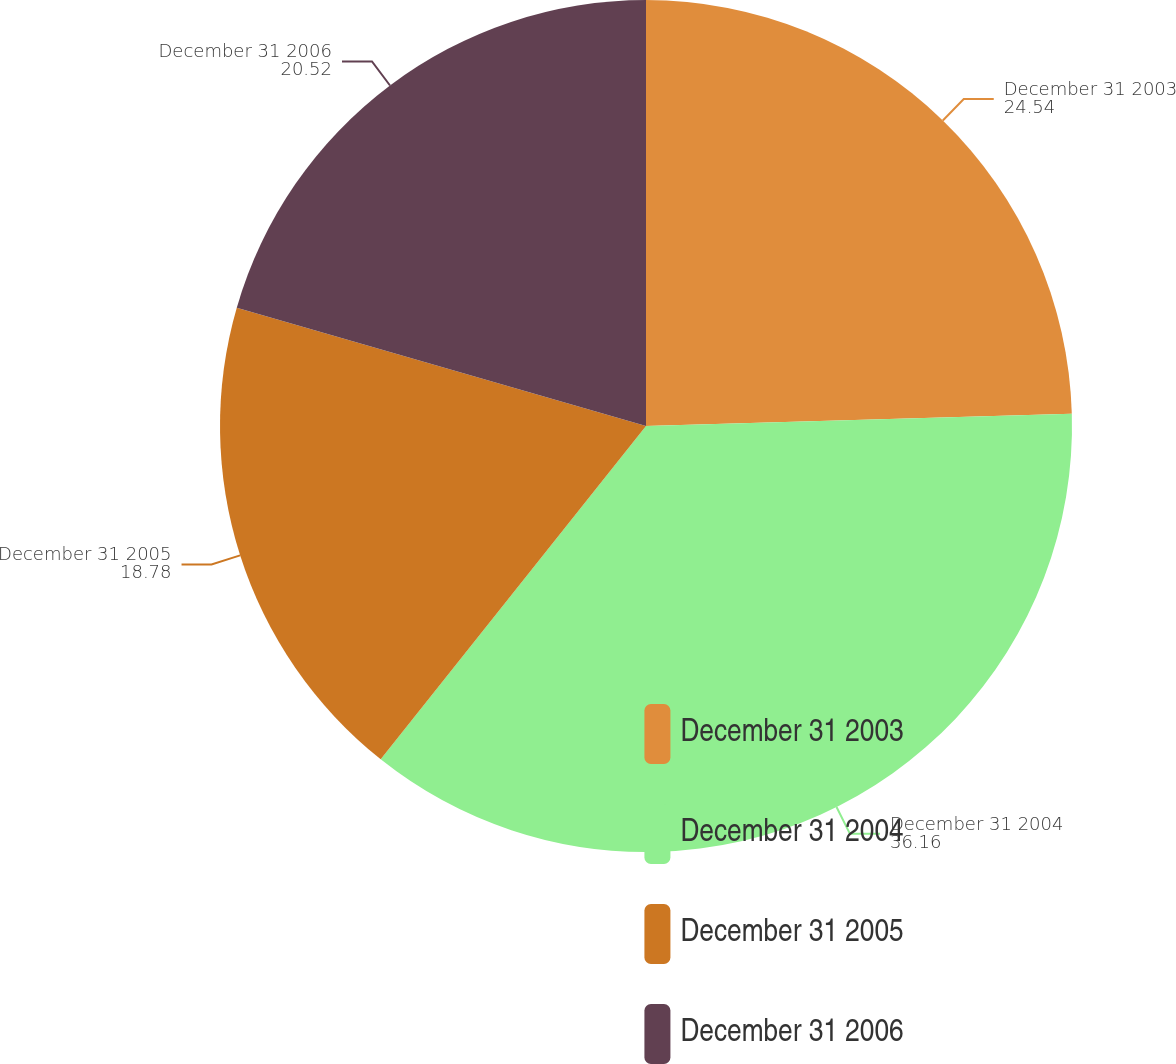Convert chart to OTSL. <chart><loc_0><loc_0><loc_500><loc_500><pie_chart><fcel>December 31 2003<fcel>December 31 2004<fcel>December 31 2005<fcel>December 31 2006<nl><fcel>24.54%<fcel>36.16%<fcel>18.78%<fcel>20.52%<nl></chart> 